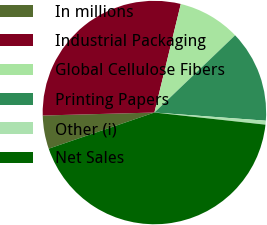Convert chart to OTSL. <chart><loc_0><loc_0><loc_500><loc_500><pie_chart><fcel>In millions<fcel>Industrial Packaging<fcel>Global Cellulose Fibers<fcel>Printing Papers<fcel>Other (i)<fcel>Net Sales<nl><fcel>4.82%<fcel>29.22%<fcel>9.06%<fcel>13.31%<fcel>0.57%<fcel>43.03%<nl></chart> 